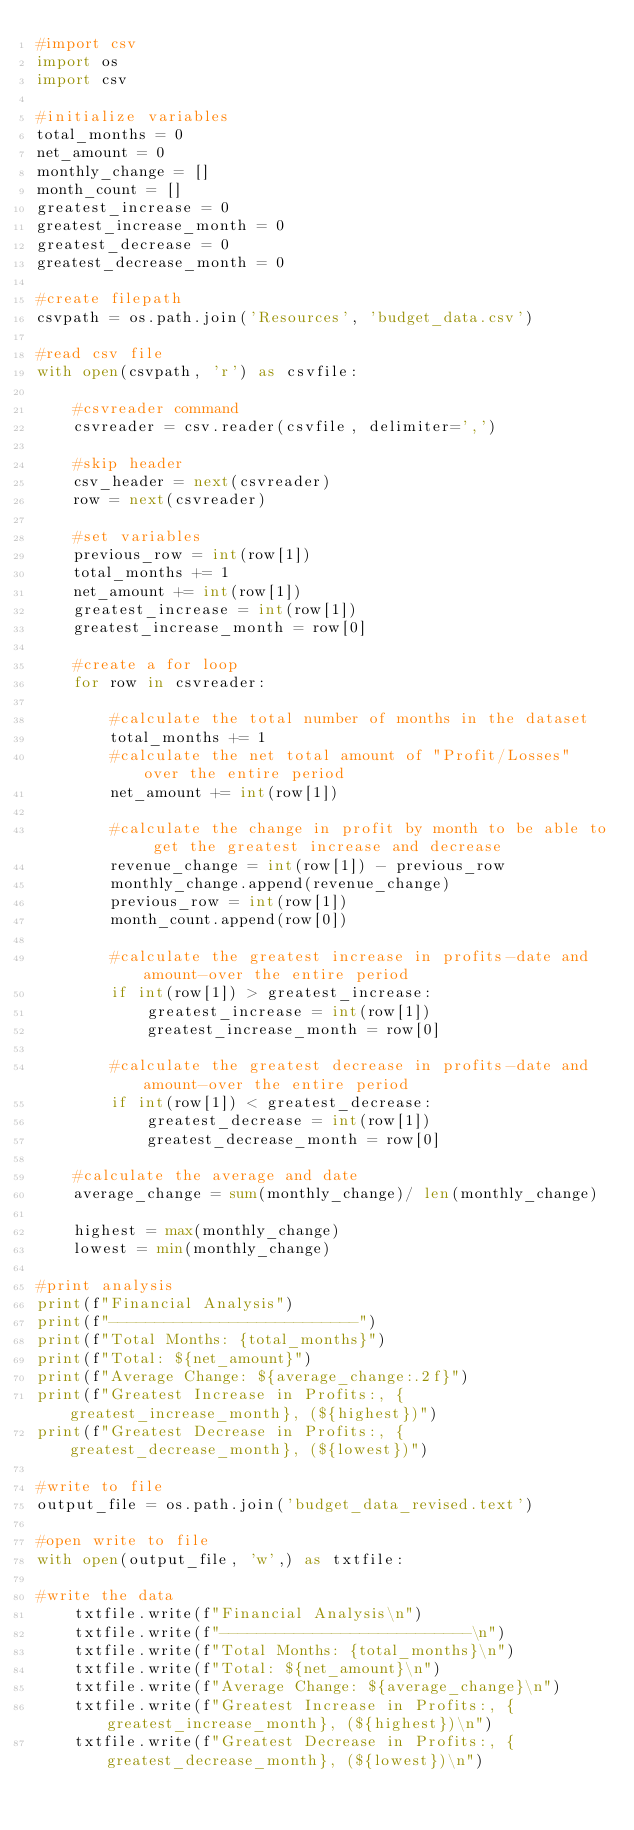<code> <loc_0><loc_0><loc_500><loc_500><_Python_>#import csv
import os
import csv

#initialize variables
total_months = 0
net_amount = 0
monthly_change = []
month_count = []
greatest_increase = 0
greatest_increase_month = 0
greatest_decrease = 0
greatest_decrease_month = 0

#create filepath
csvpath = os.path.join('Resources', 'budget_data.csv')

#read csv file
with open(csvpath, 'r') as csvfile:
    
    #csvreader command
    csvreader = csv.reader(csvfile, delimiter=',')
    
    #skip header
    csv_header = next(csvreader)
    row = next(csvreader)
    
    #set variables
    previous_row = int(row[1])
    total_months += 1
    net_amount += int(row[1])
    greatest_increase = int(row[1])
    greatest_increase_month = row[0]
    
    #create a for loop
    for row in csvreader:
        
        #calculate the total number of months in the dataset
        total_months += 1
        #calculate the net total amount of "Profit/Losses" over the entire period
        net_amount += int(row[1])

        #calculate the change in profit by month to be able to get the greatest increase and decrease
        revenue_change = int(row[1]) - previous_row
        monthly_change.append(revenue_change)
        previous_row = int(row[1])
        month_count.append(row[0])
        
        #calculate the greatest increase in profits-date and amount-over the entire period
        if int(row[1]) > greatest_increase:
            greatest_increase = int(row[1])
            greatest_increase_month = row[0]
            
        #calculate the greatest decrease in profits-date and amount-over the entire period
        if int(row[1]) < greatest_decrease:
            greatest_decrease = int(row[1])
            greatest_decrease_month = row[0]  
        
    #calculate the average and date
    average_change = sum(monthly_change)/ len(monthly_change)
    
    highest = max(monthly_change)
    lowest = min(monthly_change)

#print analysis
print(f"Financial Analysis")
print(f"---------------------------")
print(f"Total Months: {total_months}")
print(f"Total: ${net_amount}")
print(f"Average Change: ${average_change:.2f}")
print(f"Greatest Increase in Profits:, {greatest_increase_month}, (${highest})")
print(f"Greatest Decrease in Profits:, {greatest_decrease_month}, (${lowest})")

#write to file
output_file = os.path.join('budget_data_revised.text')

#open write to file
with open(output_file, 'w',) as txtfile:

#write the data
    txtfile.write(f"Financial Analysis\n")
    txtfile.write(f"---------------------------\n")
    txtfile.write(f"Total Months: {total_months}\n")
    txtfile.write(f"Total: ${net_amount}\n")
    txtfile.write(f"Average Change: ${average_change}\n")
    txtfile.write(f"Greatest Increase in Profits:, {greatest_increase_month}, (${highest})\n")
    txtfile.write(f"Greatest Decrease in Profits:, {greatest_decrease_month}, (${lowest})\n")</code> 